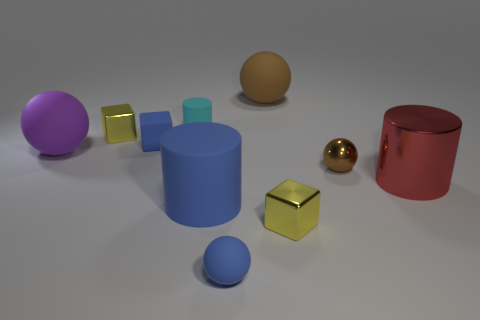There is a cylinder that is the same color as the tiny matte ball; what is its size?
Your answer should be compact. Large. There is a large object that is in front of the big red thing; is it the same shape as the tiny matte thing behind the blue matte block?
Give a very brief answer. Yes. What is the big red thing made of?
Make the answer very short. Metal. What shape is the big thing that is the same color as the small metallic ball?
Ensure brevity in your answer.  Sphere. What number of brown shiny objects have the same size as the purple thing?
Ensure brevity in your answer.  0. What number of things are objects that are behind the purple object or objects behind the large red metal cylinder?
Provide a short and direct response. 6. Does the brown thing right of the brown matte sphere have the same material as the large sphere right of the cyan rubber cylinder?
Your answer should be very brief. No. What shape is the small yellow thing to the left of the tiny matte object in front of the red cylinder?
Offer a very short reply. Cube. Is there any other thing of the same color as the metal sphere?
Your answer should be very brief. Yes. Is there a brown thing on the right side of the small yellow metallic block in front of the small yellow thing that is behind the brown shiny ball?
Your response must be concise. Yes. 